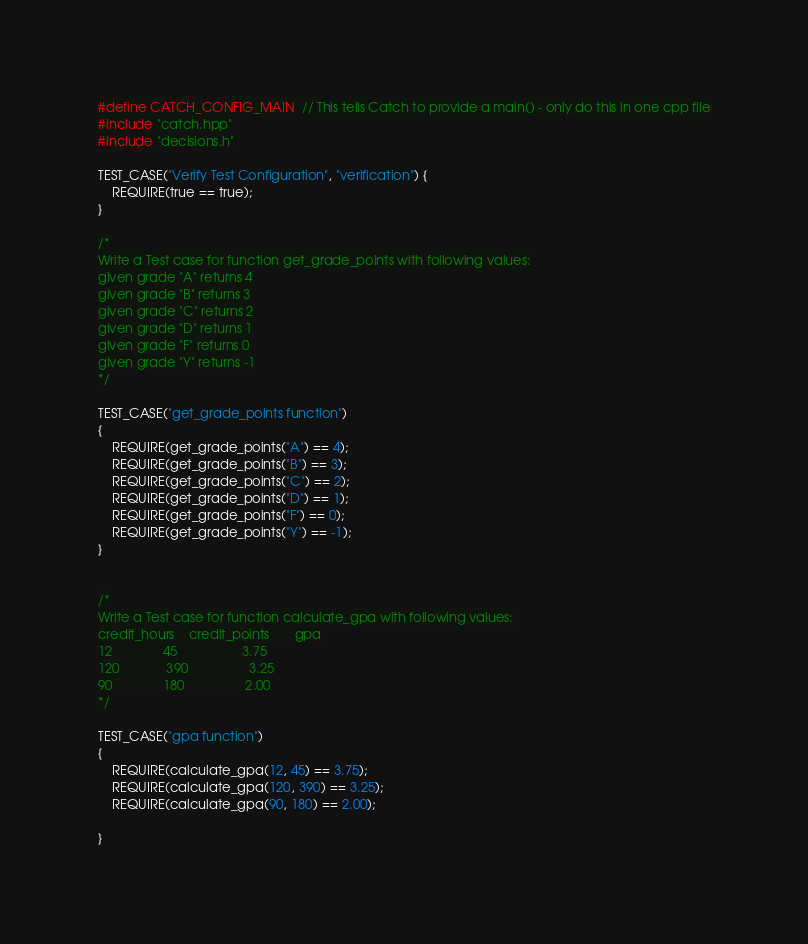<code> <loc_0><loc_0><loc_500><loc_500><_C++_>#define CATCH_CONFIG_MAIN  // This tells Catch to provide a main() - only do this in one cpp file
#include "catch.hpp"
#include "decisions.h"

TEST_CASE("Verify Test Configuration", "verification") {
	REQUIRE(true == true);
}

/*
Write a Test case for function get_grade_points with following values:
given grade "A" returns 4
given grade "B" returns 3
given grade "C" returns 2
given grade "D" returns 1
given grade "F" returns 0
given grade "Y" returns -1
*/

TEST_CASE("get_grade_points function")
{
	REQUIRE(get_grade_points("A") == 4);
	REQUIRE(get_grade_points("B") == 3);
	REQUIRE(get_grade_points("C") == 2);
	REQUIRE(get_grade_points("D") == 1);
	REQUIRE(get_grade_points("F") == 0);
	REQUIRE(get_grade_points("Y") == -1);
}


/*
Write a Test case for function calculate_gpa with following values:
credit_hours	credit_points		gpa
12				45					3.75
120				390					3.25
90				180					2.00
*/

TEST_CASE("gpa function")
{
	REQUIRE(calculate_gpa(12, 45) == 3.75);
	REQUIRE(calculate_gpa(120, 390) == 3.25);
	REQUIRE(calculate_gpa(90, 180) == 2.00);
	
}
</code> 